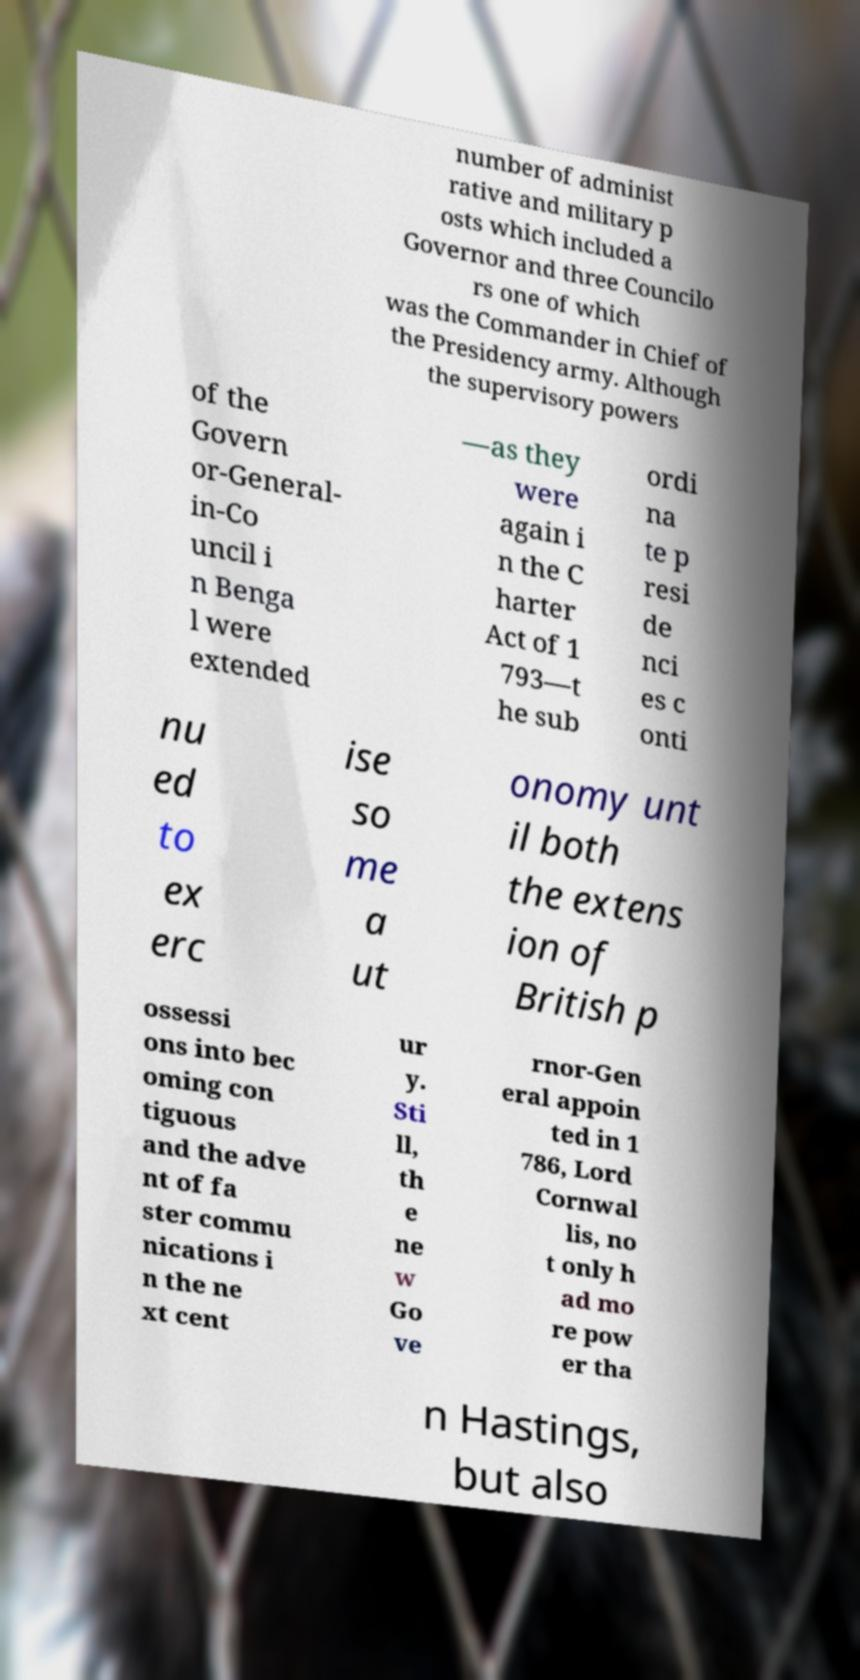Please identify and transcribe the text found in this image. number of administ rative and military p osts which included a Governor and three Councilo rs one of which was the Commander in Chief of the Presidency army. Although the supervisory powers of the Govern or-General- in-Co uncil i n Benga l were extended —as they were again i n the C harter Act of 1 793—t he sub ordi na te p resi de nci es c onti nu ed to ex erc ise so me a ut onomy unt il both the extens ion of British p ossessi ons into bec oming con tiguous and the adve nt of fa ster commu nications i n the ne xt cent ur y. Sti ll, th e ne w Go ve rnor-Gen eral appoin ted in 1 786, Lord Cornwal lis, no t only h ad mo re pow er tha n Hastings, but also 